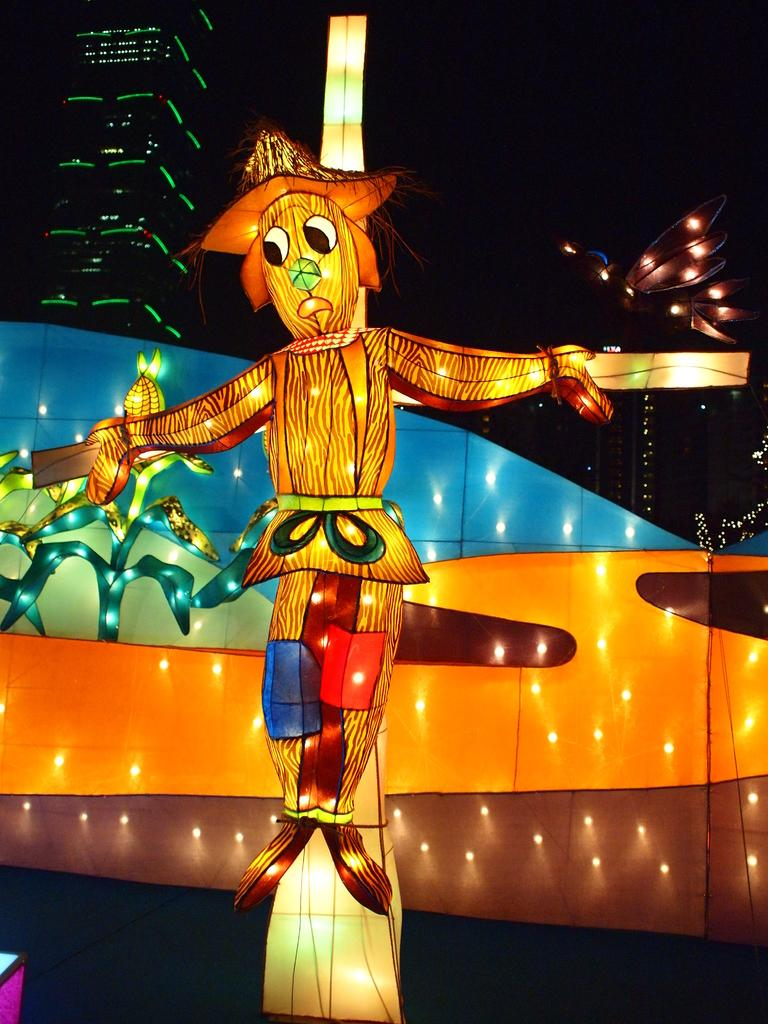What is the main subject of the image? There is a statue of a cartoon in the image. What is surrounding the cartoon statue? There are lights around the cartoon statue. What can be seen in the background of the image? There is a building in the background of the image. How many servants are attending to the cartoon statue in the image? There are no servants present in the image; it only features a cartoon statue with lights around it and a building in the background. 